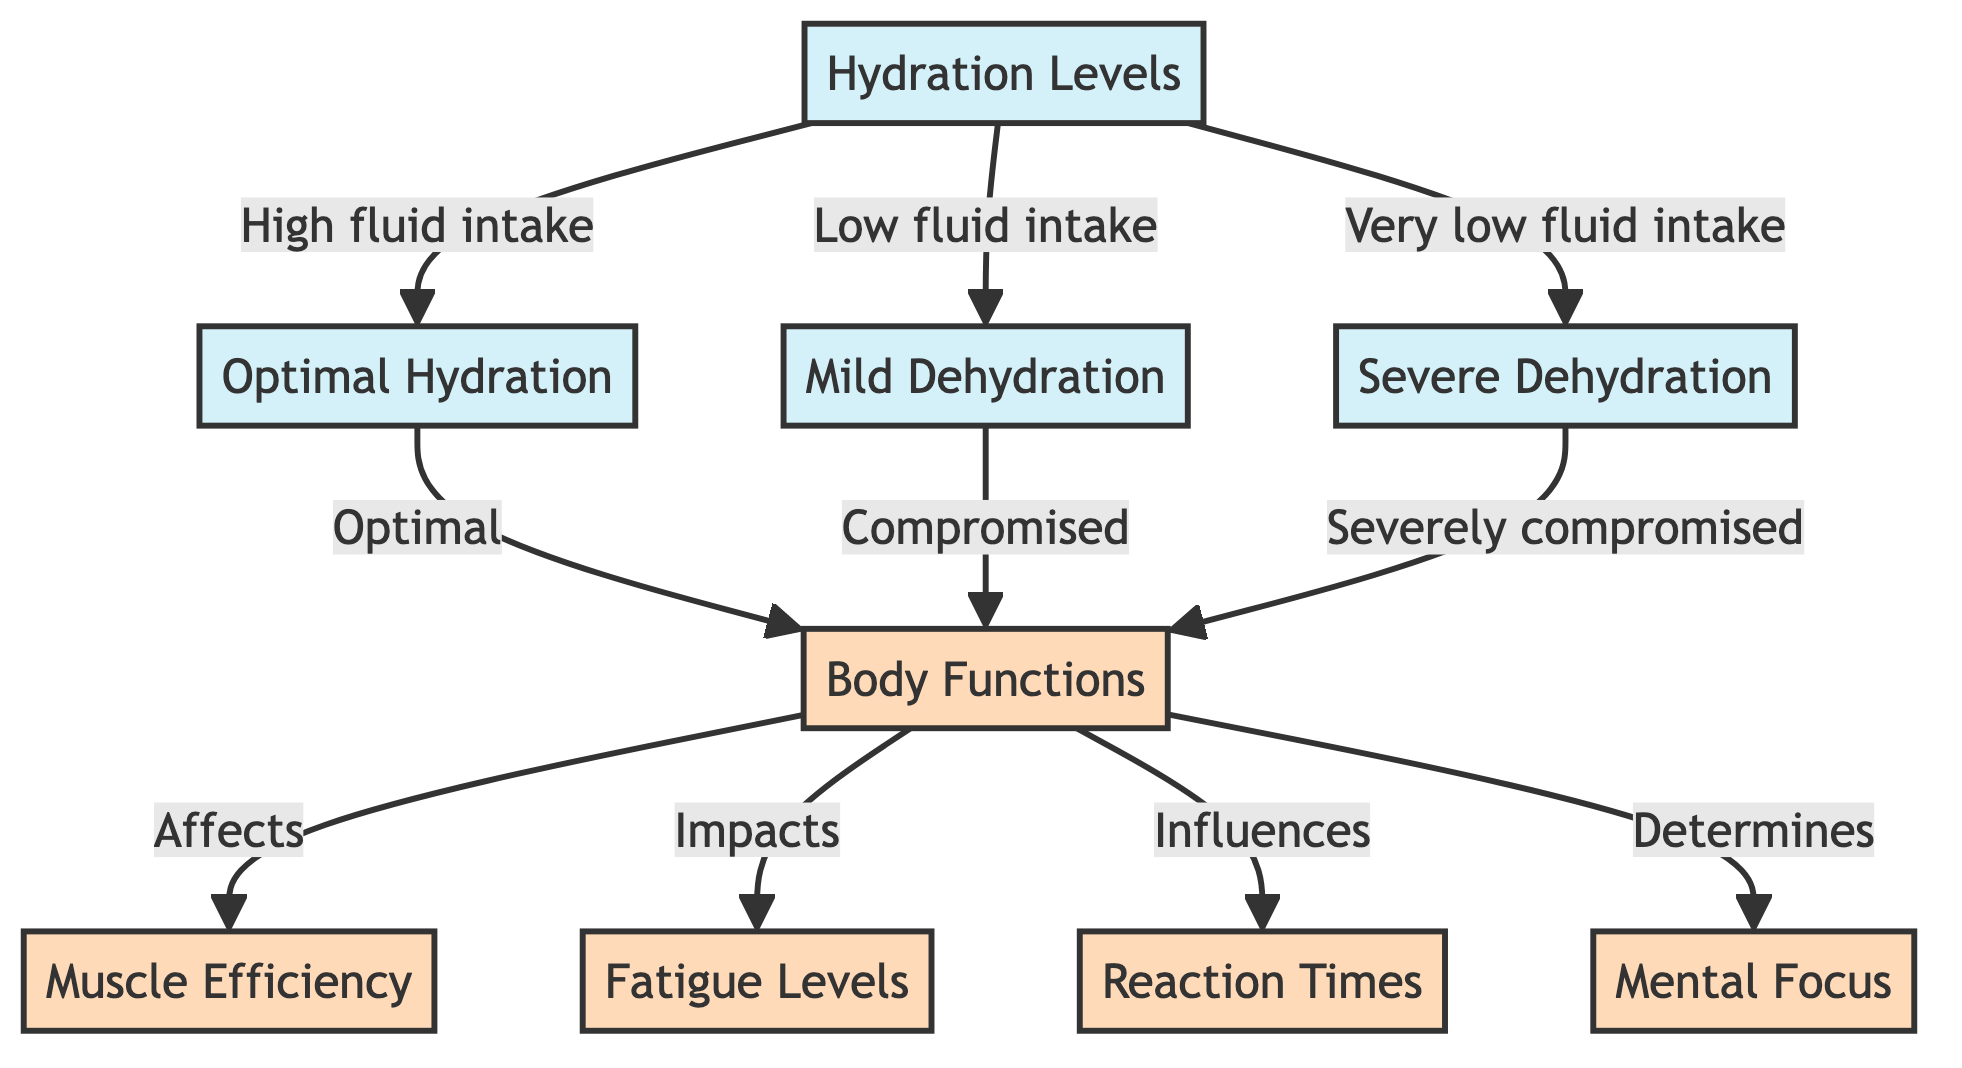What are the three hydration levels shown in the diagram? The diagram lists three hydration levels: Optimal Hydration, Mild Dehydration, and Severe Dehydration. These are labeled as distinct nodes in the flowchart.
Answer: Optimal Hydration, Mild Dehydration, Severe Dehydration What happens to body functions under mild dehydration? Mild dehydration results in compromised body functions. This is indicated by the flow from the mild dehydration node to the body functions node, which states it is compromised.
Answer: Compromised How does severe dehydration affect muscle efficiency? Severe dehydration severely compromises body functions, which affects muscle efficiency as indicated by the diagram's connections. Thus, it negatively impacts muscle efficiency.
Answer: Severely compromised Which hydration level relates to optimal body functions? The hydration level that is optimal is directly linked to body functions in the diagram. The flow indicates that optimal hydration leads to the best state for body functions.
Answer: Optimal Hydration What are the four body function impacts shown in the diagram? The impacts on body functions include muscle efficiency, fatigue levels, reaction times, and mental focus. Each of these is shown as a distinct effect of the body's function status in the diagram.
Answer: Muscle Efficiency, Fatigue Levels, Reaction Times, Mental Focus How does high fluid intake affect hydration levels? High fluid intake leads to optimal hydration, as indicated by the direct connection from the hydration levels node to optimal hydration node in the diagram.
Answer: Optimal Hydration Which dehydration level has the greatest impact on mental focus? Severe dehydration has the greatest impact on mental focus according to the diagram. The connections show that severe dehydration leads to severely compromised body functions, which directly influence mental focus.
Answer: Severe Dehydration What is the relationship between body functions and fatigue levels? Body functions are indicated to impact fatigue levels significantly, as the diagram illustrates a direct link where body functions influence fatigue levels.
Answer: Impacts Which hydration level corresponds with low fluid intake? Mild dehydration corresponds with low fluid intake, as represented in the diagram with a direct link from hydration levels.
Answer: Mild Dehydration 